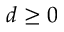<formula> <loc_0><loc_0><loc_500><loc_500>d \geq 0</formula> 